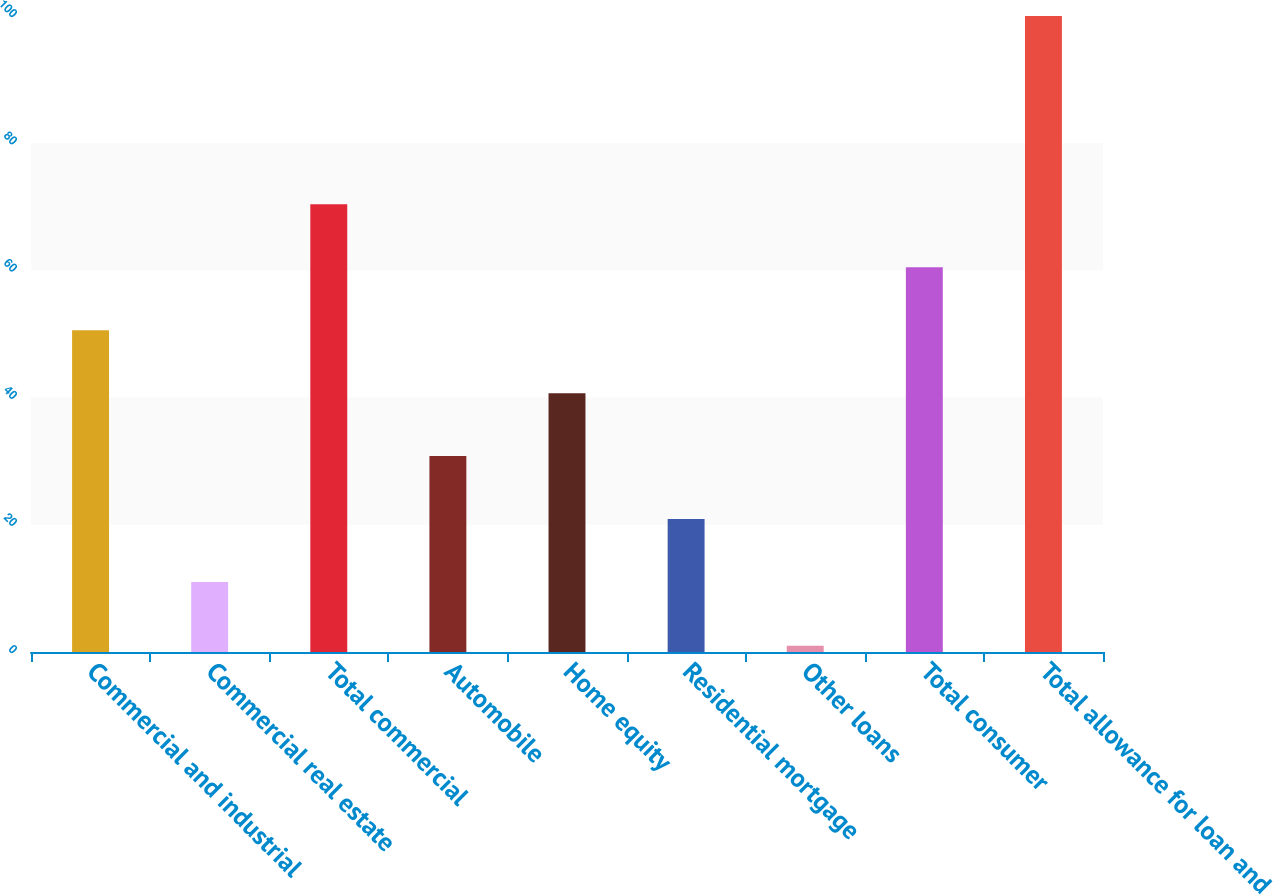Convert chart to OTSL. <chart><loc_0><loc_0><loc_500><loc_500><bar_chart><fcel>Commercial and industrial<fcel>Commercial real estate<fcel>Total commercial<fcel>Automobile<fcel>Home equity<fcel>Residential mortgage<fcel>Other loans<fcel>Total consumer<fcel>Total allowance for loan and<nl><fcel>50.6<fcel>11<fcel>70.4<fcel>30.8<fcel>40.7<fcel>20.9<fcel>1<fcel>60.5<fcel>100<nl></chart> 